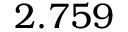Convert formula to latex. <formula><loc_0><loc_0><loc_500><loc_500>2 . 7 5 9</formula> 